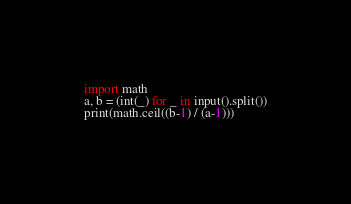Convert code to text. <code><loc_0><loc_0><loc_500><loc_500><_Python_>import math
a, b = (int(_) for _ in input().split())
print(math.ceil((b-1) / (a-1)))</code> 